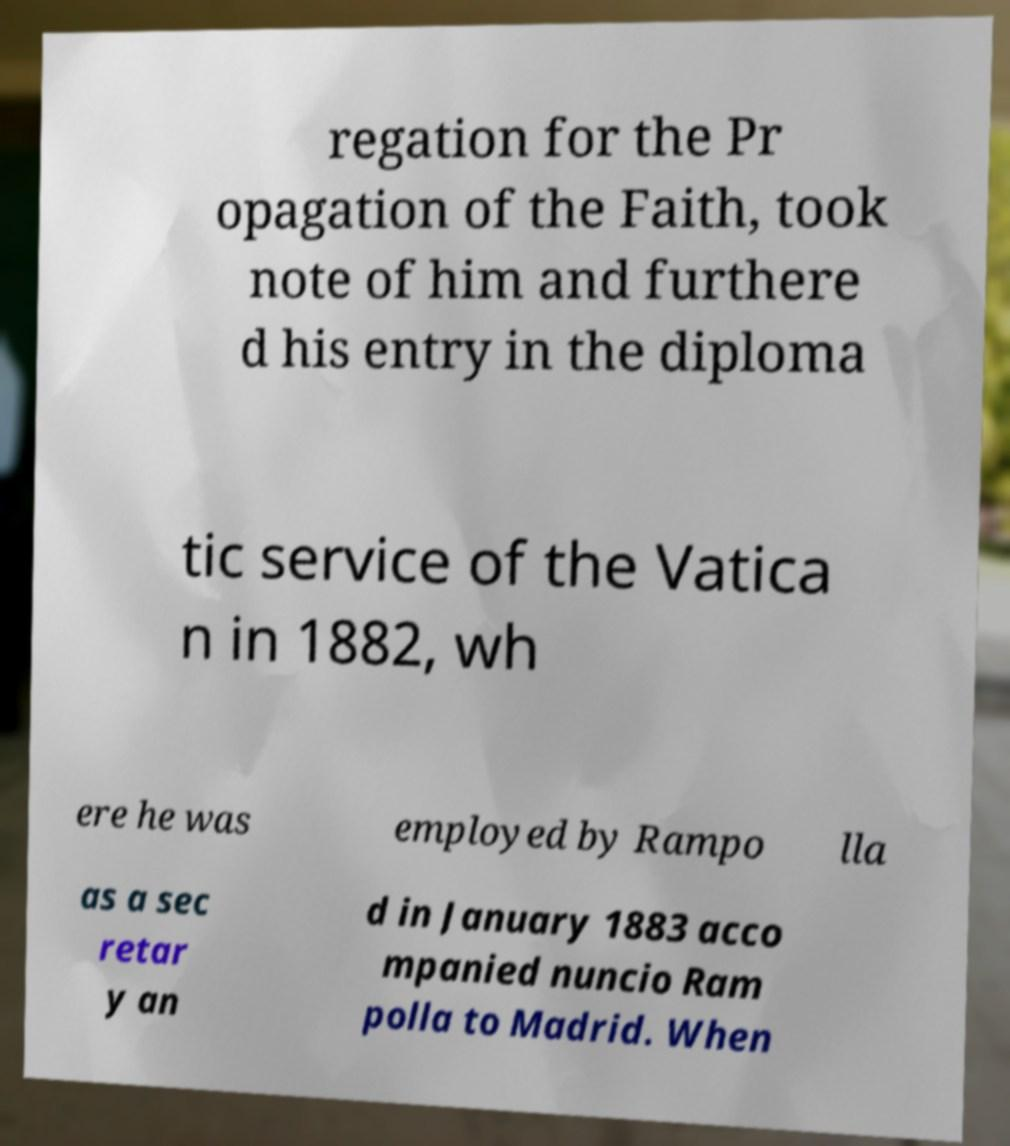Please read and relay the text visible in this image. What does it say? regation for the Pr opagation of the Faith, took note of him and furthere d his entry in the diploma tic service of the Vatica n in 1882, wh ere he was employed by Rampo lla as a sec retar y an d in January 1883 acco mpanied nuncio Ram polla to Madrid. When 